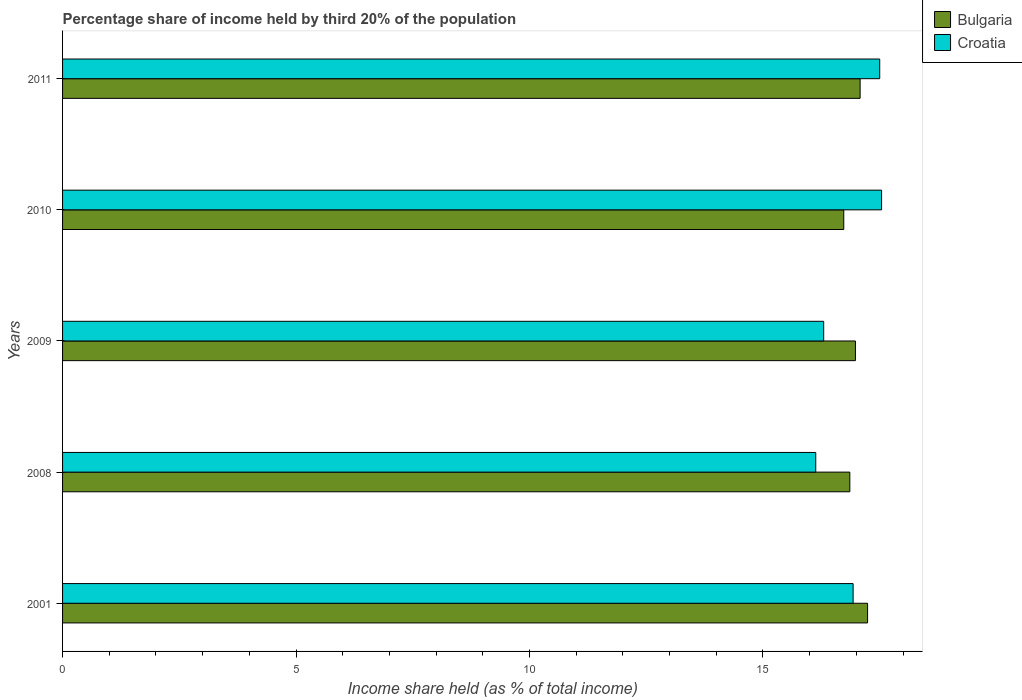How many different coloured bars are there?
Provide a succinct answer. 2. How many groups of bars are there?
Provide a short and direct response. 5. Are the number of bars on each tick of the Y-axis equal?
Keep it short and to the point. Yes. What is the label of the 5th group of bars from the top?
Your answer should be compact. 2001. What is the share of income held by third 20% of the population in Croatia in 2011?
Offer a terse response. 17.5. Across all years, what is the maximum share of income held by third 20% of the population in Croatia?
Keep it short and to the point. 17.54. Across all years, what is the minimum share of income held by third 20% of the population in Bulgaria?
Your answer should be compact. 16.73. In which year was the share of income held by third 20% of the population in Bulgaria maximum?
Give a very brief answer. 2001. What is the total share of income held by third 20% of the population in Bulgaria in the graph?
Give a very brief answer. 84.89. What is the difference between the share of income held by third 20% of the population in Croatia in 2001 and that in 2009?
Your answer should be compact. 0.63. What is the difference between the share of income held by third 20% of the population in Bulgaria in 2010 and the share of income held by third 20% of the population in Croatia in 2009?
Your answer should be very brief. 0.43. What is the average share of income held by third 20% of the population in Bulgaria per year?
Make the answer very short. 16.98. In the year 2001, what is the difference between the share of income held by third 20% of the population in Bulgaria and share of income held by third 20% of the population in Croatia?
Give a very brief answer. 0.31. What is the ratio of the share of income held by third 20% of the population in Croatia in 2001 to that in 2009?
Offer a very short reply. 1.04. Is the difference between the share of income held by third 20% of the population in Bulgaria in 2008 and 2010 greater than the difference between the share of income held by third 20% of the population in Croatia in 2008 and 2010?
Ensure brevity in your answer.  Yes. What is the difference between the highest and the second highest share of income held by third 20% of the population in Bulgaria?
Offer a terse response. 0.16. What is the difference between the highest and the lowest share of income held by third 20% of the population in Bulgaria?
Make the answer very short. 0.51. In how many years, is the share of income held by third 20% of the population in Bulgaria greater than the average share of income held by third 20% of the population in Bulgaria taken over all years?
Provide a succinct answer. 3. Is the sum of the share of income held by third 20% of the population in Croatia in 2008 and 2010 greater than the maximum share of income held by third 20% of the population in Bulgaria across all years?
Your answer should be very brief. Yes. What does the 2nd bar from the bottom in 2001 represents?
Your answer should be compact. Croatia. How many bars are there?
Provide a succinct answer. 10. How many years are there in the graph?
Offer a very short reply. 5. What is the difference between two consecutive major ticks on the X-axis?
Give a very brief answer. 5. Does the graph contain any zero values?
Provide a short and direct response. No. Does the graph contain grids?
Offer a very short reply. No. How are the legend labels stacked?
Offer a terse response. Vertical. What is the title of the graph?
Keep it short and to the point. Percentage share of income held by third 20% of the population. What is the label or title of the X-axis?
Provide a succinct answer. Income share held (as % of total income). What is the Income share held (as % of total income) of Bulgaria in 2001?
Your answer should be compact. 17.24. What is the Income share held (as % of total income) in Croatia in 2001?
Ensure brevity in your answer.  16.93. What is the Income share held (as % of total income) in Bulgaria in 2008?
Provide a succinct answer. 16.86. What is the Income share held (as % of total income) in Croatia in 2008?
Ensure brevity in your answer.  16.13. What is the Income share held (as % of total income) in Bulgaria in 2009?
Your response must be concise. 16.98. What is the Income share held (as % of total income) of Bulgaria in 2010?
Provide a short and direct response. 16.73. What is the Income share held (as % of total income) in Croatia in 2010?
Give a very brief answer. 17.54. What is the Income share held (as % of total income) of Bulgaria in 2011?
Make the answer very short. 17.08. What is the Income share held (as % of total income) in Croatia in 2011?
Keep it short and to the point. 17.5. Across all years, what is the maximum Income share held (as % of total income) in Bulgaria?
Provide a succinct answer. 17.24. Across all years, what is the maximum Income share held (as % of total income) in Croatia?
Your answer should be very brief. 17.54. Across all years, what is the minimum Income share held (as % of total income) in Bulgaria?
Give a very brief answer. 16.73. Across all years, what is the minimum Income share held (as % of total income) of Croatia?
Your response must be concise. 16.13. What is the total Income share held (as % of total income) of Bulgaria in the graph?
Provide a succinct answer. 84.89. What is the total Income share held (as % of total income) in Croatia in the graph?
Keep it short and to the point. 84.4. What is the difference between the Income share held (as % of total income) in Bulgaria in 2001 and that in 2008?
Offer a terse response. 0.38. What is the difference between the Income share held (as % of total income) in Bulgaria in 2001 and that in 2009?
Give a very brief answer. 0.26. What is the difference between the Income share held (as % of total income) in Croatia in 2001 and that in 2009?
Give a very brief answer. 0.63. What is the difference between the Income share held (as % of total income) in Bulgaria in 2001 and that in 2010?
Provide a short and direct response. 0.51. What is the difference between the Income share held (as % of total income) of Croatia in 2001 and that in 2010?
Provide a succinct answer. -0.61. What is the difference between the Income share held (as % of total income) in Bulgaria in 2001 and that in 2011?
Provide a succinct answer. 0.16. What is the difference between the Income share held (as % of total income) in Croatia in 2001 and that in 2011?
Your response must be concise. -0.57. What is the difference between the Income share held (as % of total income) of Bulgaria in 2008 and that in 2009?
Your response must be concise. -0.12. What is the difference between the Income share held (as % of total income) of Croatia in 2008 and that in 2009?
Provide a short and direct response. -0.17. What is the difference between the Income share held (as % of total income) of Bulgaria in 2008 and that in 2010?
Your answer should be compact. 0.13. What is the difference between the Income share held (as % of total income) in Croatia in 2008 and that in 2010?
Your answer should be very brief. -1.41. What is the difference between the Income share held (as % of total income) of Bulgaria in 2008 and that in 2011?
Provide a short and direct response. -0.22. What is the difference between the Income share held (as % of total income) in Croatia in 2008 and that in 2011?
Provide a short and direct response. -1.37. What is the difference between the Income share held (as % of total income) of Croatia in 2009 and that in 2010?
Keep it short and to the point. -1.24. What is the difference between the Income share held (as % of total income) of Bulgaria in 2010 and that in 2011?
Provide a short and direct response. -0.35. What is the difference between the Income share held (as % of total income) of Bulgaria in 2001 and the Income share held (as % of total income) of Croatia in 2008?
Provide a succinct answer. 1.11. What is the difference between the Income share held (as % of total income) of Bulgaria in 2001 and the Income share held (as % of total income) of Croatia in 2011?
Give a very brief answer. -0.26. What is the difference between the Income share held (as % of total income) of Bulgaria in 2008 and the Income share held (as % of total income) of Croatia in 2009?
Provide a succinct answer. 0.56. What is the difference between the Income share held (as % of total income) in Bulgaria in 2008 and the Income share held (as % of total income) in Croatia in 2010?
Make the answer very short. -0.68. What is the difference between the Income share held (as % of total income) in Bulgaria in 2008 and the Income share held (as % of total income) in Croatia in 2011?
Your response must be concise. -0.64. What is the difference between the Income share held (as % of total income) in Bulgaria in 2009 and the Income share held (as % of total income) in Croatia in 2010?
Offer a terse response. -0.56. What is the difference between the Income share held (as % of total income) in Bulgaria in 2009 and the Income share held (as % of total income) in Croatia in 2011?
Your response must be concise. -0.52. What is the difference between the Income share held (as % of total income) in Bulgaria in 2010 and the Income share held (as % of total income) in Croatia in 2011?
Ensure brevity in your answer.  -0.77. What is the average Income share held (as % of total income) of Bulgaria per year?
Give a very brief answer. 16.98. What is the average Income share held (as % of total income) of Croatia per year?
Make the answer very short. 16.88. In the year 2001, what is the difference between the Income share held (as % of total income) of Bulgaria and Income share held (as % of total income) of Croatia?
Keep it short and to the point. 0.31. In the year 2008, what is the difference between the Income share held (as % of total income) of Bulgaria and Income share held (as % of total income) of Croatia?
Offer a very short reply. 0.73. In the year 2009, what is the difference between the Income share held (as % of total income) in Bulgaria and Income share held (as % of total income) in Croatia?
Give a very brief answer. 0.68. In the year 2010, what is the difference between the Income share held (as % of total income) of Bulgaria and Income share held (as % of total income) of Croatia?
Your answer should be very brief. -0.81. In the year 2011, what is the difference between the Income share held (as % of total income) in Bulgaria and Income share held (as % of total income) in Croatia?
Your answer should be compact. -0.42. What is the ratio of the Income share held (as % of total income) in Bulgaria in 2001 to that in 2008?
Give a very brief answer. 1.02. What is the ratio of the Income share held (as % of total income) of Croatia in 2001 to that in 2008?
Give a very brief answer. 1.05. What is the ratio of the Income share held (as % of total income) of Bulgaria in 2001 to that in 2009?
Ensure brevity in your answer.  1.02. What is the ratio of the Income share held (as % of total income) in Croatia in 2001 to that in 2009?
Make the answer very short. 1.04. What is the ratio of the Income share held (as % of total income) in Bulgaria in 2001 to that in 2010?
Your answer should be compact. 1.03. What is the ratio of the Income share held (as % of total income) in Croatia in 2001 to that in 2010?
Provide a succinct answer. 0.97. What is the ratio of the Income share held (as % of total income) in Bulgaria in 2001 to that in 2011?
Offer a very short reply. 1.01. What is the ratio of the Income share held (as % of total income) in Croatia in 2001 to that in 2011?
Provide a succinct answer. 0.97. What is the ratio of the Income share held (as % of total income) in Croatia in 2008 to that in 2009?
Your answer should be very brief. 0.99. What is the ratio of the Income share held (as % of total income) of Bulgaria in 2008 to that in 2010?
Your answer should be very brief. 1.01. What is the ratio of the Income share held (as % of total income) in Croatia in 2008 to that in 2010?
Make the answer very short. 0.92. What is the ratio of the Income share held (as % of total income) of Bulgaria in 2008 to that in 2011?
Make the answer very short. 0.99. What is the ratio of the Income share held (as % of total income) of Croatia in 2008 to that in 2011?
Offer a terse response. 0.92. What is the ratio of the Income share held (as % of total income) in Bulgaria in 2009 to that in 2010?
Your answer should be very brief. 1.01. What is the ratio of the Income share held (as % of total income) of Croatia in 2009 to that in 2010?
Offer a terse response. 0.93. What is the ratio of the Income share held (as % of total income) of Croatia in 2009 to that in 2011?
Give a very brief answer. 0.93. What is the ratio of the Income share held (as % of total income) of Bulgaria in 2010 to that in 2011?
Your answer should be very brief. 0.98. What is the difference between the highest and the second highest Income share held (as % of total income) of Bulgaria?
Give a very brief answer. 0.16. What is the difference between the highest and the second highest Income share held (as % of total income) of Croatia?
Offer a terse response. 0.04. What is the difference between the highest and the lowest Income share held (as % of total income) in Bulgaria?
Your answer should be compact. 0.51. What is the difference between the highest and the lowest Income share held (as % of total income) of Croatia?
Ensure brevity in your answer.  1.41. 